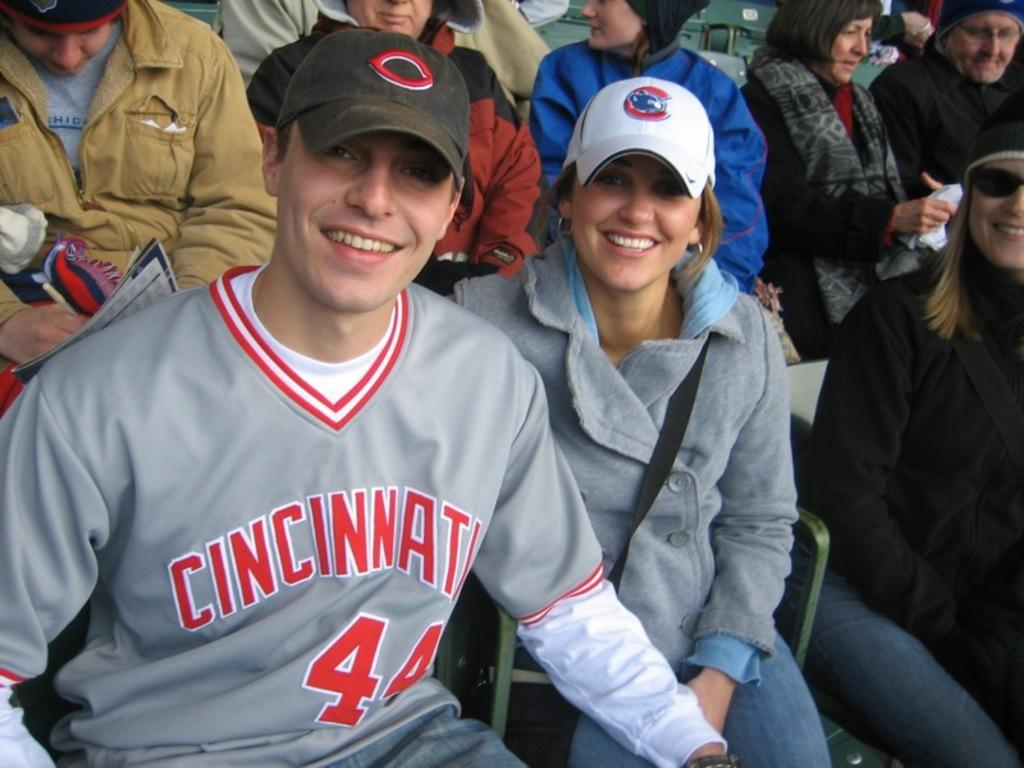Provide a one-sentence caption for the provided image. Two people smiling at a sports game in Cincinnati. 